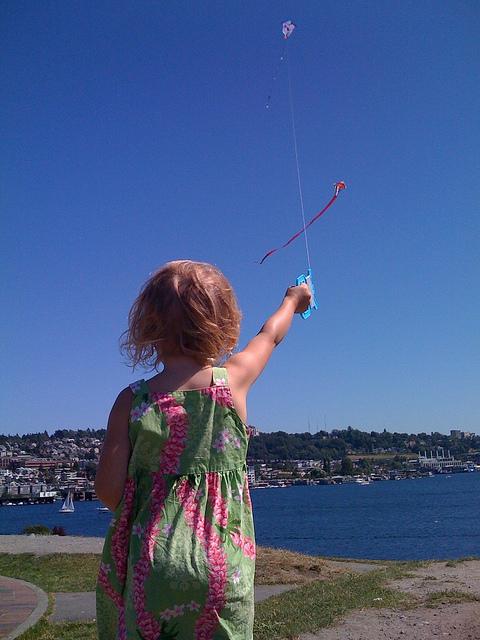What is the girl wearing?
Quick response, please. Dress. Does this girl look like she's in elementary school?
Write a very short answer. Yes. What is the girl doing?
Keep it brief. Flying kite. 